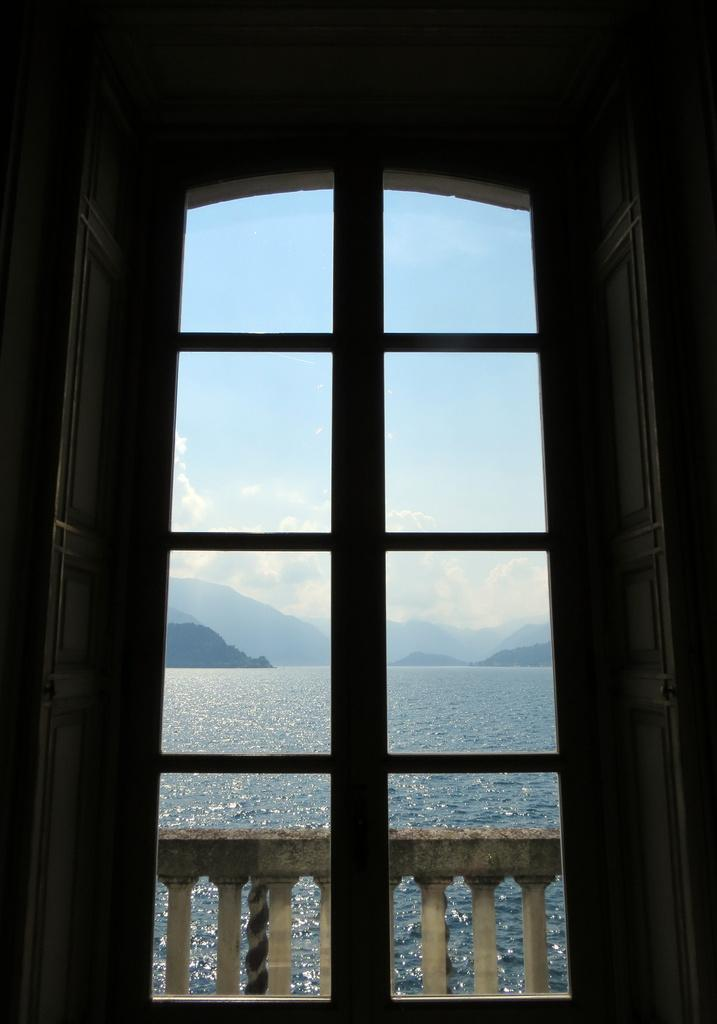What can be seen through the window in the image? Railing, water, hills, and the sky are visible through the window in the image. Can you describe the view through the window? The view through the window includes railing, water, hills, and the sky. What type of landscape is visible through the window? The landscape visible through the window includes hills and water. What part of the natural environment is visible through the window? The sky is visible through the window. What type of pollution can be seen in the image? There is no pollution visible in the image. Is there a hospital visible in the image? There is no hospital present in the image. 